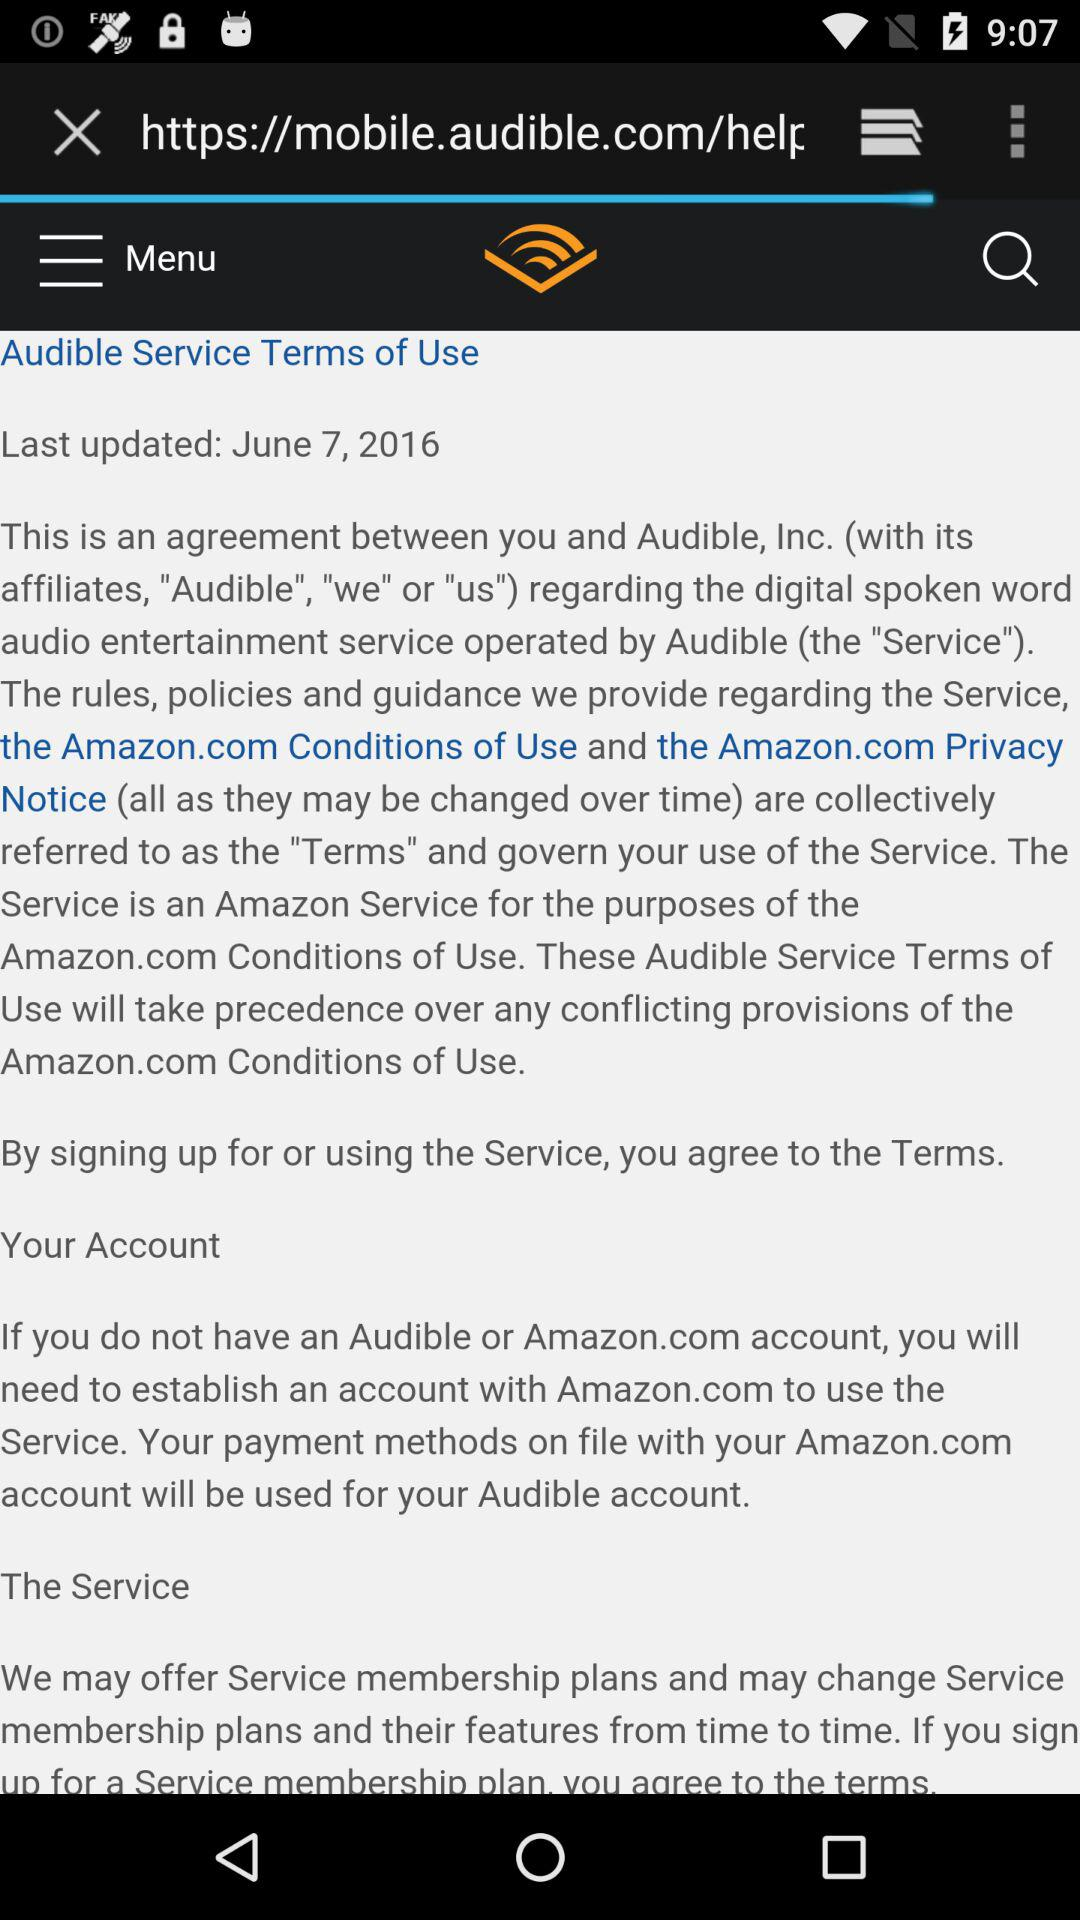What is the last updated date of the "Audible Service Terms of Use"? The last updated date is June 7, 2016. 